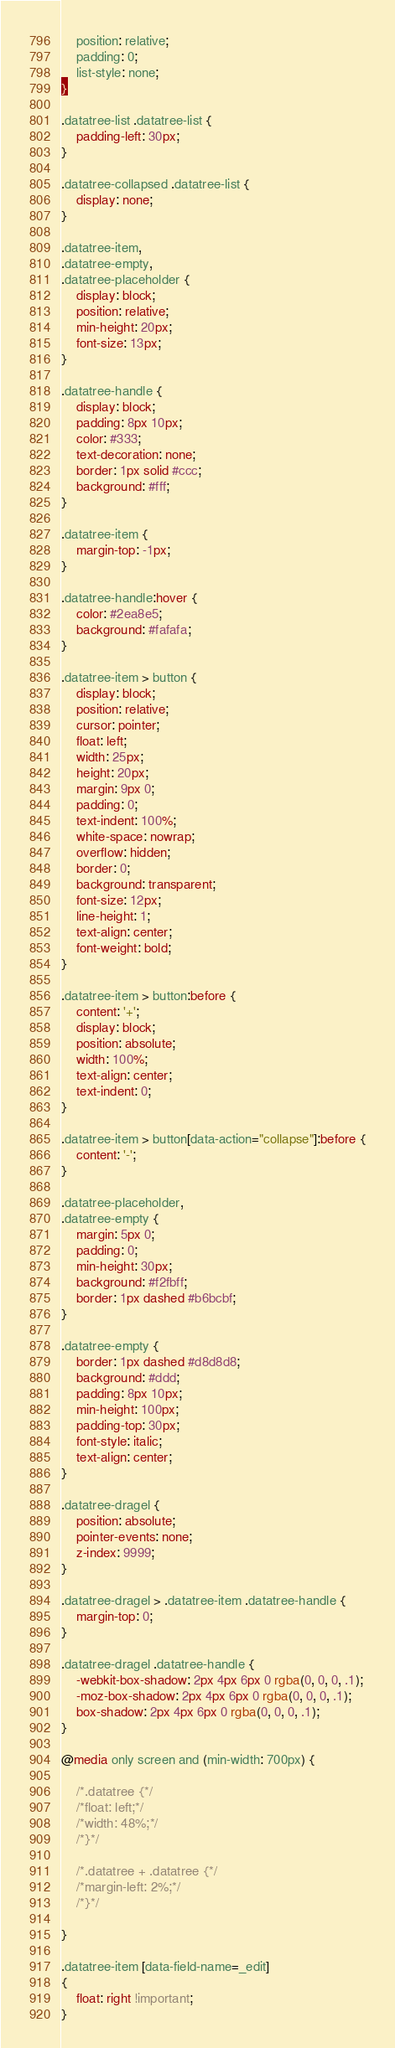<code> <loc_0><loc_0><loc_500><loc_500><_CSS_>    position: relative;
    padding: 0;
    list-style: none;
}

.datatree-list .datatree-list {
    padding-left: 30px;
}

.datatree-collapsed .datatree-list {
    display: none;
}

.datatree-item,
.datatree-empty,
.datatree-placeholder {
    display: block;
    position: relative;
    min-height: 20px;
    font-size: 13px;
}

.datatree-handle {
    display: block;
    padding: 8px 10px;
    color: #333;
    text-decoration: none;
    border: 1px solid #ccc;
    background: #fff;
}

.datatree-item {
    margin-top: -1px;
}

.datatree-handle:hover {
    color: #2ea8e5;
    background: #fafafa;
}

.datatree-item > button {
    display: block;
    position: relative;
    cursor: pointer;
    float: left;
    width: 25px;
    height: 20px;
    margin: 9px 0;
    padding: 0;
    text-indent: 100%;
    white-space: nowrap;
    overflow: hidden;
    border: 0;
    background: transparent;
    font-size: 12px;
    line-height: 1;
    text-align: center;
    font-weight: bold;
}

.datatree-item > button:before {
    content: '+';
    display: block;
    position: absolute;
    width: 100%;
    text-align: center;
    text-indent: 0;
}

.datatree-item > button[data-action="collapse"]:before {
    content: '-';
}

.datatree-placeholder,
.datatree-empty {
    margin: 5px 0;
    padding: 0;
    min-height: 30px;
    background: #f2fbff;
    border: 1px dashed #b6bcbf;
}

.datatree-empty {
    border: 1px dashed #d8d8d8;
    background: #ddd;
    padding: 8px 10px;
    min-height: 100px;
    padding-top: 30px;
    font-style: italic;
    text-align: center;
}

.datatree-dragel {
    position: absolute;
    pointer-events: none;
    z-index: 9999;
}

.datatree-dragel > .datatree-item .datatree-handle {
    margin-top: 0;
}

.datatree-dragel .datatree-handle {
    -webkit-box-shadow: 2px 4px 6px 0 rgba(0, 0, 0, .1);
    -moz-box-shadow: 2px 4px 6px 0 rgba(0, 0, 0, .1);
    box-shadow: 2px 4px 6px 0 rgba(0, 0, 0, .1);
}

@media only screen and (min-width: 700px) {

    /*.datatree {*/
    /*float: left;*/
    /*width: 48%;*/
    /*}*/

    /*.datatree + .datatree {*/
    /*margin-left: 2%;*/
    /*}*/

}

.datatree-item [data-field-name=_edit]
{
    float: right !important;
}</code> 